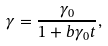Convert formula to latex. <formula><loc_0><loc_0><loc_500><loc_500>\gamma = \frac { \gamma _ { 0 } } { 1 + b \gamma _ { 0 } t } ,</formula> 